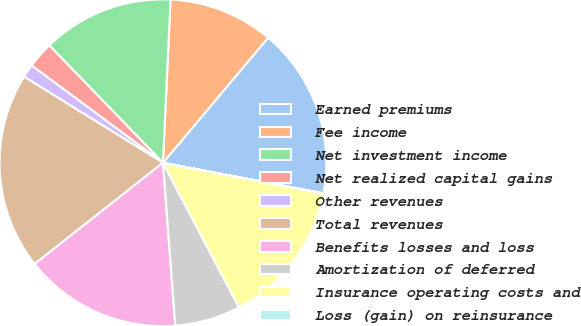Convert chart to OTSL. <chart><loc_0><loc_0><loc_500><loc_500><pie_chart><fcel>Earned premiums<fcel>Fee income<fcel>Net investment income<fcel>Net realized capital gains<fcel>Other revenues<fcel>Total revenues<fcel>Benefits losses and loss<fcel>Amortization of deferred<fcel>Insurance operating costs and<fcel>Loss (gain) on reinsurance<nl><fcel>16.87%<fcel>10.39%<fcel>12.98%<fcel>2.61%<fcel>1.32%<fcel>19.46%<fcel>15.57%<fcel>6.5%<fcel>14.28%<fcel>0.02%<nl></chart> 